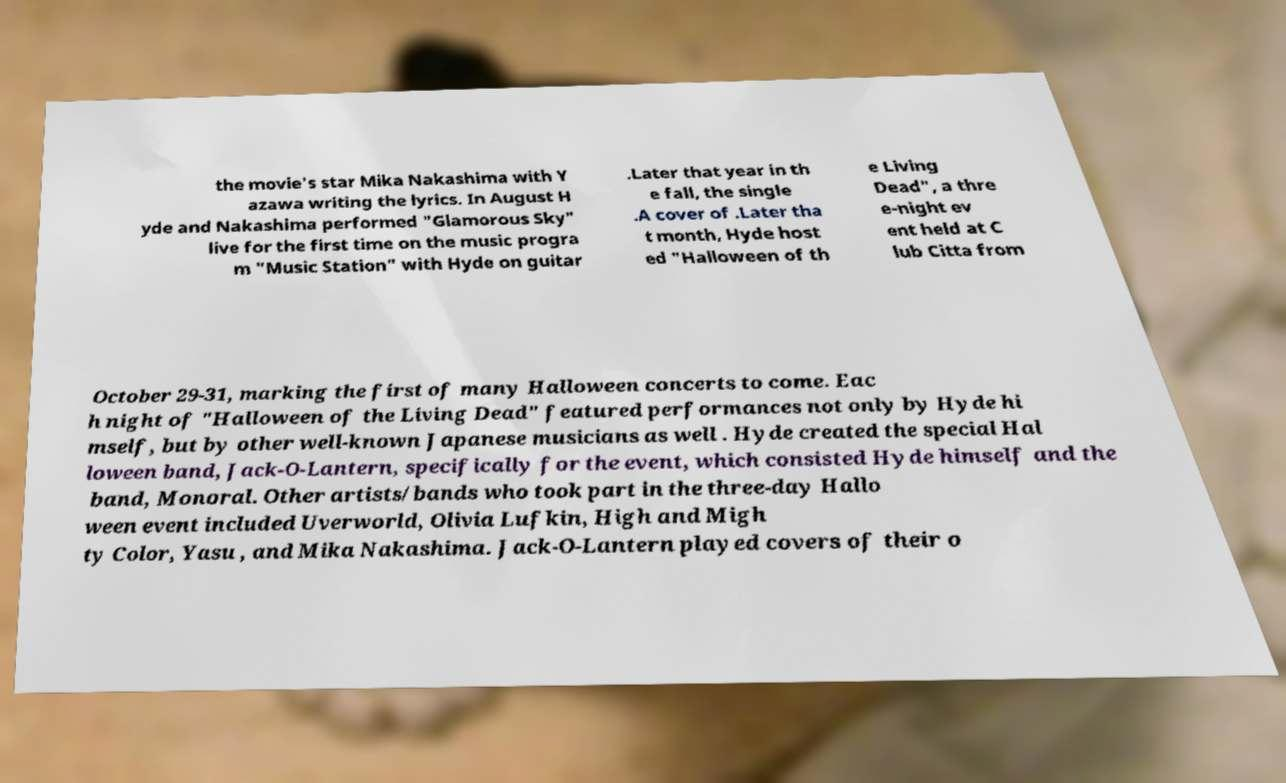There's text embedded in this image that I need extracted. Can you transcribe it verbatim? the movie's star Mika Nakashima with Y azawa writing the lyrics. In August H yde and Nakashima performed "Glamorous Sky" live for the first time on the music progra m "Music Station" with Hyde on guitar .Later that year in th e fall, the single .A cover of .Later tha t month, Hyde host ed "Halloween of th e Living Dead", a thre e-night ev ent held at C lub Citta from October 29-31, marking the first of many Halloween concerts to come. Eac h night of "Halloween of the Living Dead" featured performances not only by Hyde hi mself, but by other well-known Japanese musicians as well . Hyde created the special Hal loween band, Jack-O-Lantern, specifically for the event, which consisted Hyde himself and the band, Monoral. Other artists/bands who took part in the three-day Hallo ween event included Uverworld, Olivia Lufkin, High and Migh ty Color, Yasu , and Mika Nakashima. Jack-O-Lantern played covers of their o 